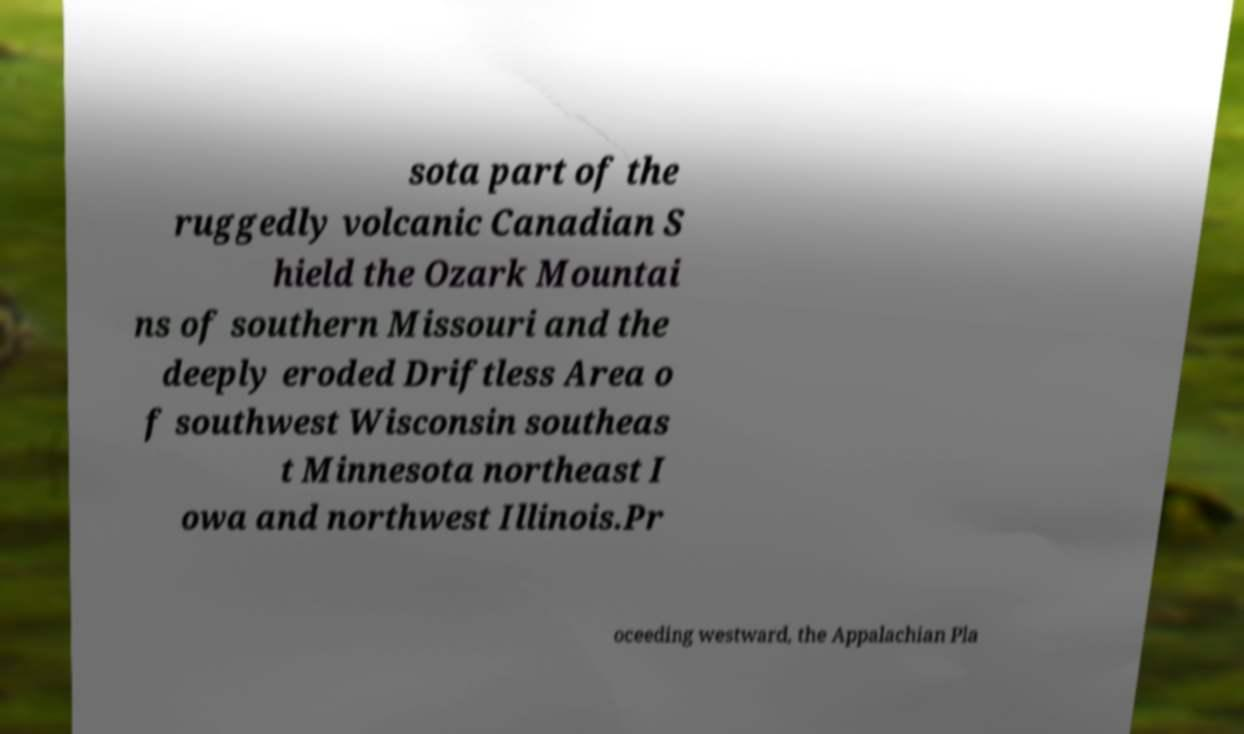For documentation purposes, I need the text within this image transcribed. Could you provide that? sota part of the ruggedly volcanic Canadian S hield the Ozark Mountai ns of southern Missouri and the deeply eroded Driftless Area o f southwest Wisconsin southeas t Minnesota northeast I owa and northwest Illinois.Pr oceeding westward, the Appalachian Pla 